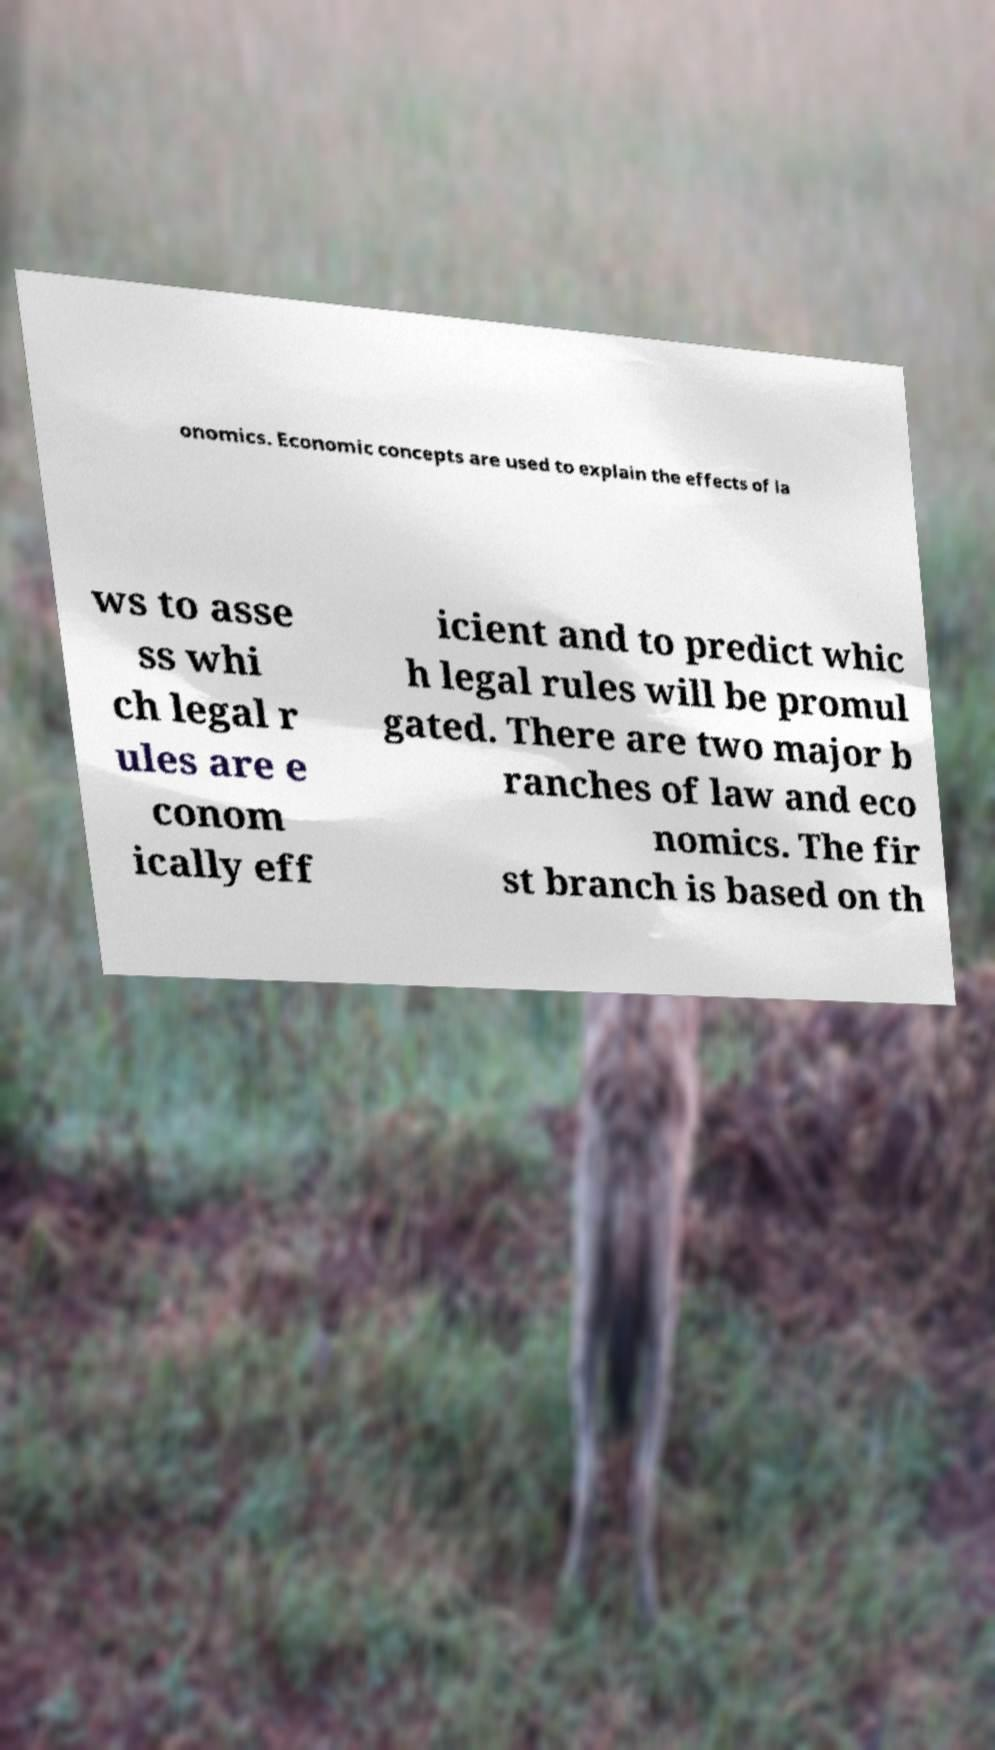Can you accurately transcribe the text from the provided image for me? onomics. Economic concepts are used to explain the effects of la ws to asse ss whi ch legal r ules are e conom ically eff icient and to predict whic h legal rules will be promul gated. There are two major b ranches of law and eco nomics. The fir st branch is based on th 